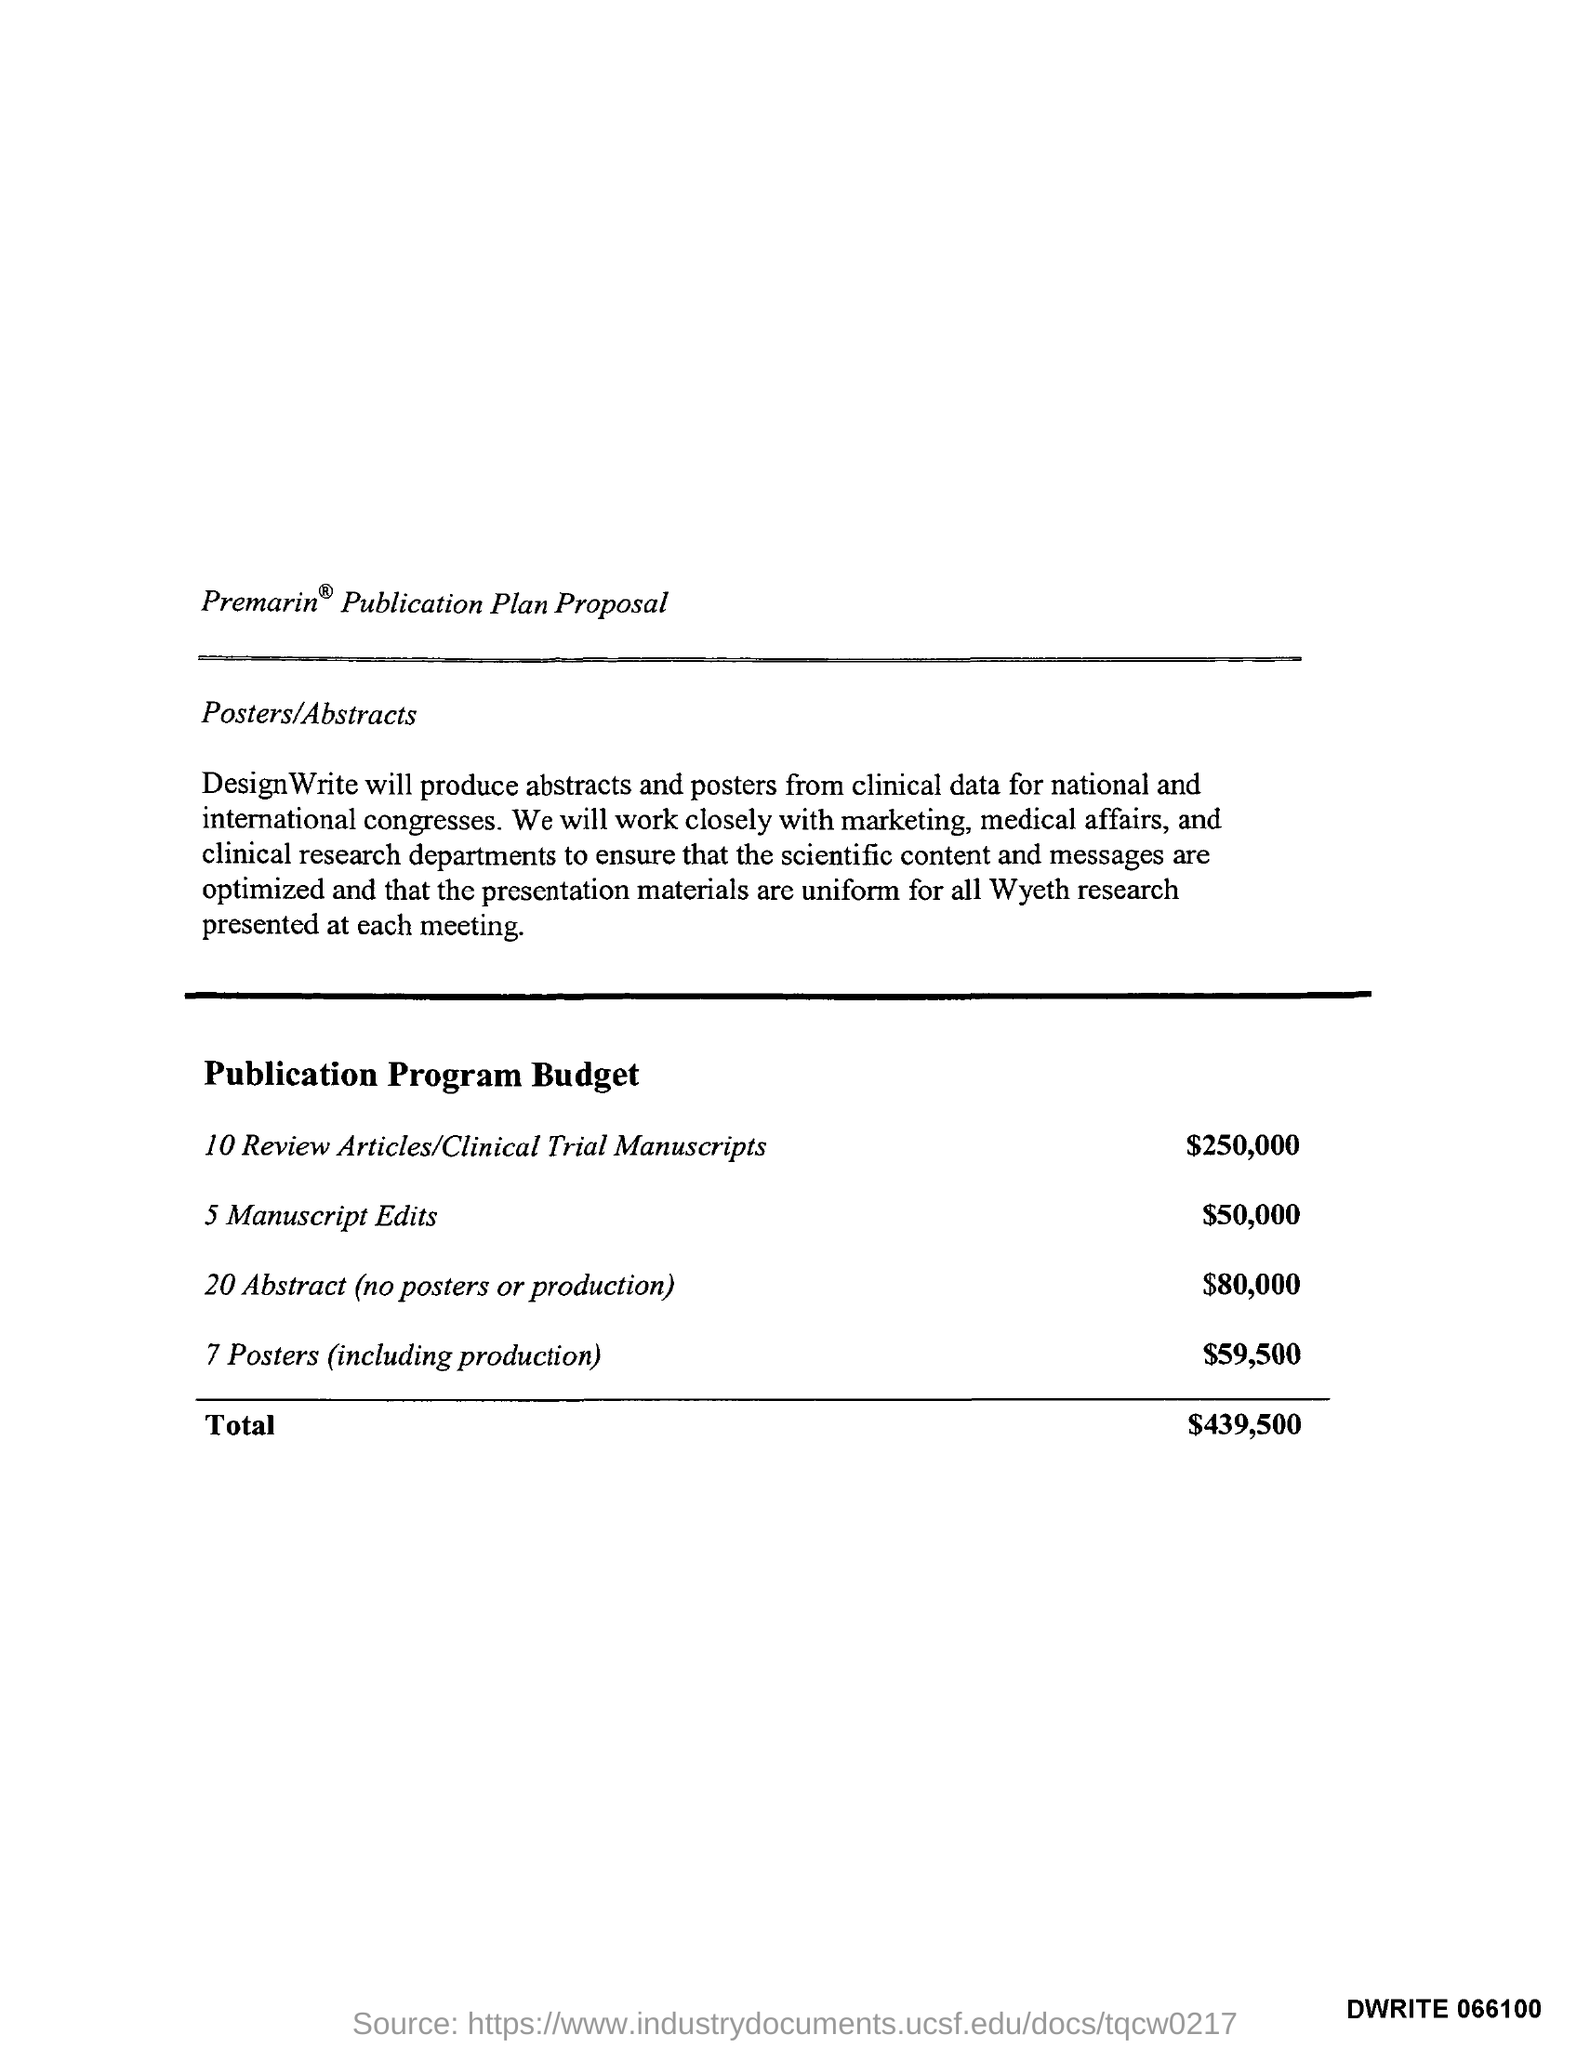Point out several critical features in this image. It is companies or individuals who specialize in the production of abstracts and posters from clinical data that are responsible for producing them for national and international congresses, specifically in the areas of design and writing. 